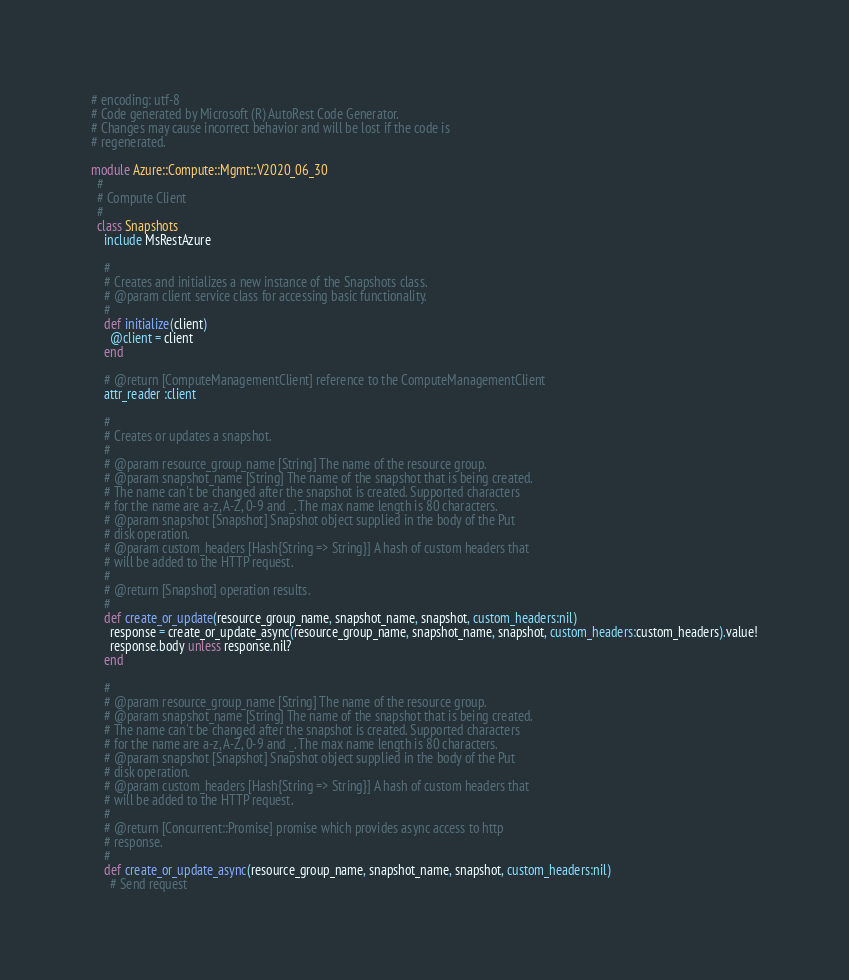<code> <loc_0><loc_0><loc_500><loc_500><_Ruby_># encoding: utf-8
# Code generated by Microsoft (R) AutoRest Code Generator.
# Changes may cause incorrect behavior and will be lost if the code is
# regenerated.

module Azure::Compute::Mgmt::V2020_06_30
  #
  # Compute Client
  #
  class Snapshots
    include MsRestAzure

    #
    # Creates and initializes a new instance of the Snapshots class.
    # @param client service class for accessing basic functionality.
    #
    def initialize(client)
      @client = client
    end

    # @return [ComputeManagementClient] reference to the ComputeManagementClient
    attr_reader :client

    #
    # Creates or updates a snapshot.
    #
    # @param resource_group_name [String] The name of the resource group.
    # @param snapshot_name [String] The name of the snapshot that is being created.
    # The name can't be changed after the snapshot is created. Supported characters
    # for the name are a-z, A-Z, 0-9 and _. The max name length is 80 characters.
    # @param snapshot [Snapshot] Snapshot object supplied in the body of the Put
    # disk operation.
    # @param custom_headers [Hash{String => String}] A hash of custom headers that
    # will be added to the HTTP request.
    #
    # @return [Snapshot] operation results.
    #
    def create_or_update(resource_group_name, snapshot_name, snapshot, custom_headers:nil)
      response = create_or_update_async(resource_group_name, snapshot_name, snapshot, custom_headers:custom_headers).value!
      response.body unless response.nil?
    end

    #
    # @param resource_group_name [String] The name of the resource group.
    # @param snapshot_name [String] The name of the snapshot that is being created.
    # The name can't be changed after the snapshot is created. Supported characters
    # for the name are a-z, A-Z, 0-9 and _. The max name length is 80 characters.
    # @param snapshot [Snapshot] Snapshot object supplied in the body of the Put
    # disk operation.
    # @param custom_headers [Hash{String => String}] A hash of custom headers that
    # will be added to the HTTP request.
    #
    # @return [Concurrent::Promise] promise which provides async access to http
    # response.
    #
    def create_or_update_async(resource_group_name, snapshot_name, snapshot, custom_headers:nil)
      # Send request</code> 